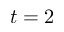<formula> <loc_0><loc_0><loc_500><loc_500>t = 2</formula> 